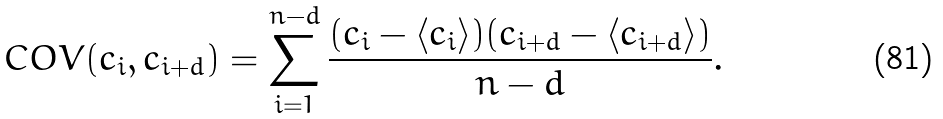Convert formula to latex. <formula><loc_0><loc_0><loc_500><loc_500>C O V ( c _ { i } , c _ { i + d } ) = \sum _ { i = 1 } ^ { n - d } \frac { ( c _ { i } - \left < c _ { i } \right > ) ( c _ { i + d } - \left < c _ { i + d } \right > ) } { n - d } .</formula> 